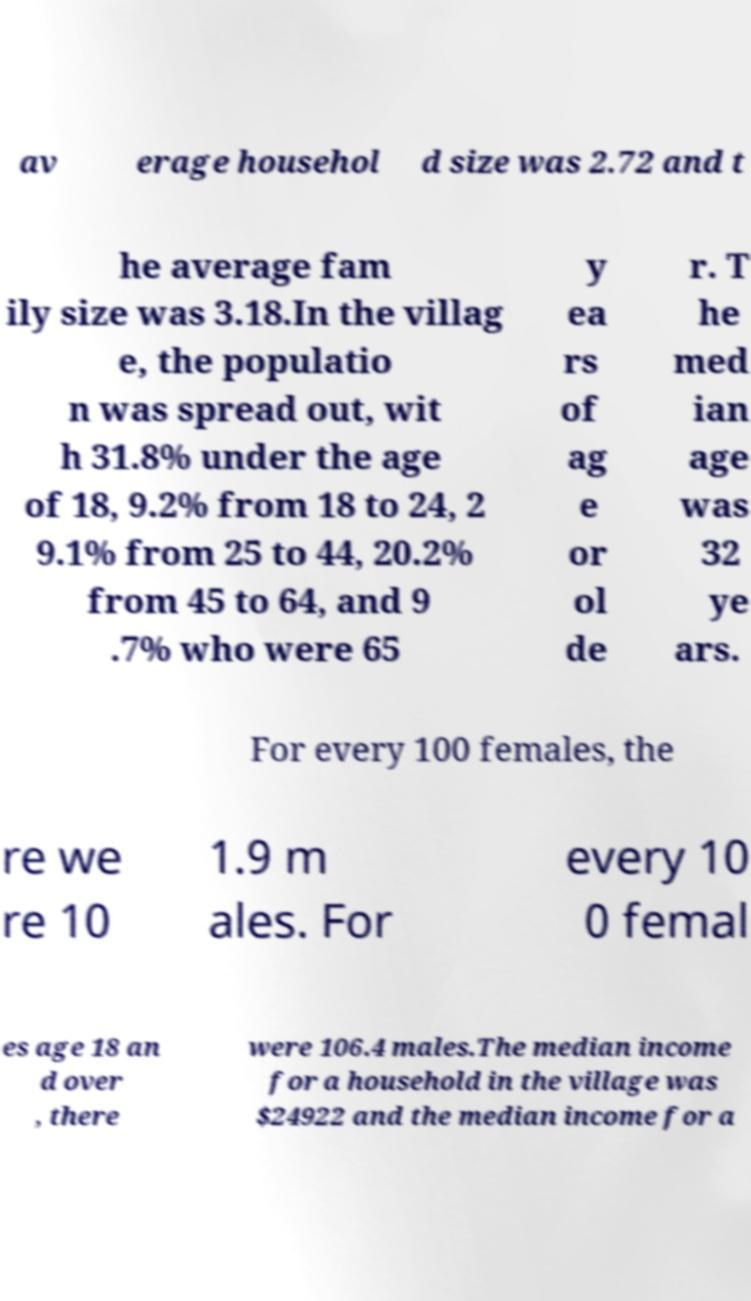Please read and relay the text visible in this image. What does it say? av erage househol d size was 2.72 and t he average fam ily size was 3.18.In the villag e, the populatio n was spread out, wit h 31.8% under the age of 18, 9.2% from 18 to 24, 2 9.1% from 25 to 44, 20.2% from 45 to 64, and 9 .7% who were 65 y ea rs of ag e or ol de r. T he med ian age was 32 ye ars. For every 100 females, the re we re 10 1.9 m ales. For every 10 0 femal es age 18 an d over , there were 106.4 males.The median income for a household in the village was $24922 and the median income for a 